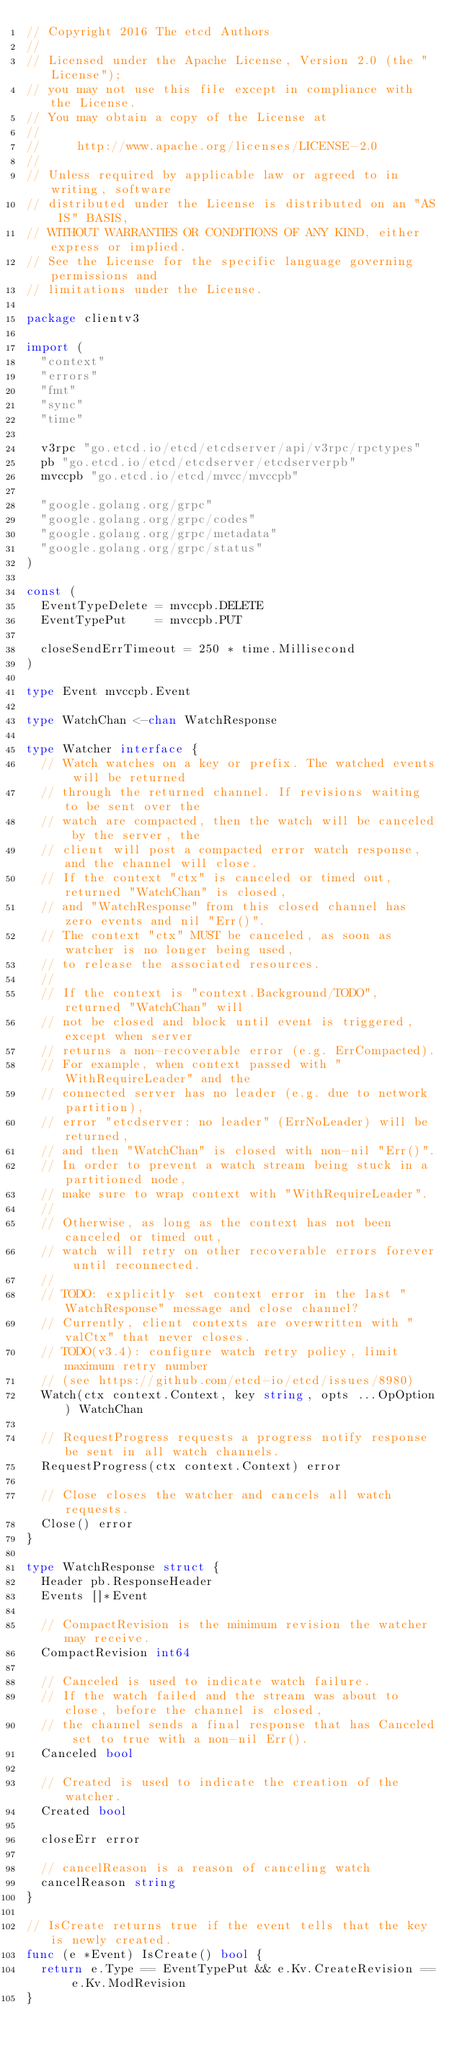<code> <loc_0><loc_0><loc_500><loc_500><_Go_>// Copyright 2016 The etcd Authors
//
// Licensed under the Apache License, Version 2.0 (the "License");
// you may not use this file except in compliance with the License.
// You may obtain a copy of the License at
//
//     http://www.apache.org/licenses/LICENSE-2.0
//
// Unless required by applicable law or agreed to in writing, software
// distributed under the License is distributed on an "AS IS" BASIS,
// WITHOUT WARRANTIES OR CONDITIONS OF ANY KIND, either express or implied.
// See the License for the specific language governing permissions and
// limitations under the License.

package clientv3

import (
	"context"
	"errors"
	"fmt"
	"sync"
	"time"

	v3rpc "go.etcd.io/etcd/etcdserver/api/v3rpc/rpctypes"
	pb "go.etcd.io/etcd/etcdserver/etcdserverpb"
	mvccpb "go.etcd.io/etcd/mvcc/mvccpb"

	"google.golang.org/grpc"
	"google.golang.org/grpc/codes"
	"google.golang.org/grpc/metadata"
	"google.golang.org/grpc/status"
)

const (
	EventTypeDelete = mvccpb.DELETE
	EventTypePut    = mvccpb.PUT

	closeSendErrTimeout = 250 * time.Millisecond
)

type Event mvccpb.Event

type WatchChan <-chan WatchResponse

type Watcher interface {
	// Watch watches on a key or prefix. The watched events will be returned
	// through the returned channel. If revisions waiting to be sent over the
	// watch are compacted, then the watch will be canceled by the server, the
	// client will post a compacted error watch response, and the channel will close.
	// If the context "ctx" is canceled or timed out, returned "WatchChan" is closed,
	// and "WatchResponse" from this closed channel has zero events and nil "Err()".
	// The context "ctx" MUST be canceled, as soon as watcher is no longer being used,
	// to release the associated resources.
	//
	// If the context is "context.Background/TODO", returned "WatchChan" will
	// not be closed and block until event is triggered, except when server
	// returns a non-recoverable error (e.g. ErrCompacted).
	// For example, when context passed with "WithRequireLeader" and the
	// connected server has no leader (e.g. due to network partition),
	// error "etcdserver: no leader" (ErrNoLeader) will be returned,
	// and then "WatchChan" is closed with non-nil "Err()".
	// In order to prevent a watch stream being stuck in a partitioned node,
	// make sure to wrap context with "WithRequireLeader".
	//
	// Otherwise, as long as the context has not been canceled or timed out,
	// watch will retry on other recoverable errors forever until reconnected.
	//
	// TODO: explicitly set context error in the last "WatchResponse" message and close channel?
	// Currently, client contexts are overwritten with "valCtx" that never closes.
	// TODO(v3.4): configure watch retry policy, limit maximum retry number
	// (see https://github.com/etcd-io/etcd/issues/8980)
	Watch(ctx context.Context, key string, opts ...OpOption) WatchChan

	// RequestProgress requests a progress notify response be sent in all watch channels.
	RequestProgress(ctx context.Context) error

	// Close closes the watcher and cancels all watch requests.
	Close() error
}

type WatchResponse struct {
	Header pb.ResponseHeader
	Events []*Event

	// CompactRevision is the minimum revision the watcher may receive.
	CompactRevision int64

	// Canceled is used to indicate watch failure.
	// If the watch failed and the stream was about to close, before the channel is closed,
	// the channel sends a final response that has Canceled set to true with a non-nil Err().
	Canceled bool

	// Created is used to indicate the creation of the watcher.
	Created bool

	closeErr error

	// cancelReason is a reason of canceling watch
	cancelReason string
}

// IsCreate returns true if the event tells that the key is newly created.
func (e *Event) IsCreate() bool {
	return e.Type == EventTypePut && e.Kv.CreateRevision == e.Kv.ModRevision
}
</code> 